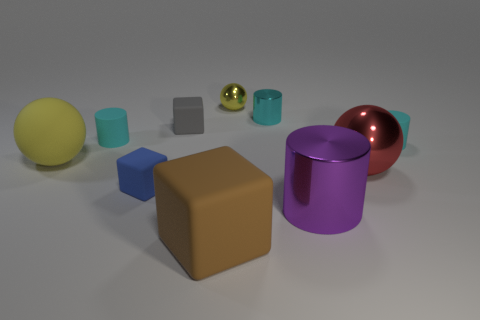Which object seems to be the largest and what is its color and shape? The largest object in the image appears to be a tan-colored cube. Its substantial size in comparison to the surrounding objects and its six equal square faces identify it as a cube. 